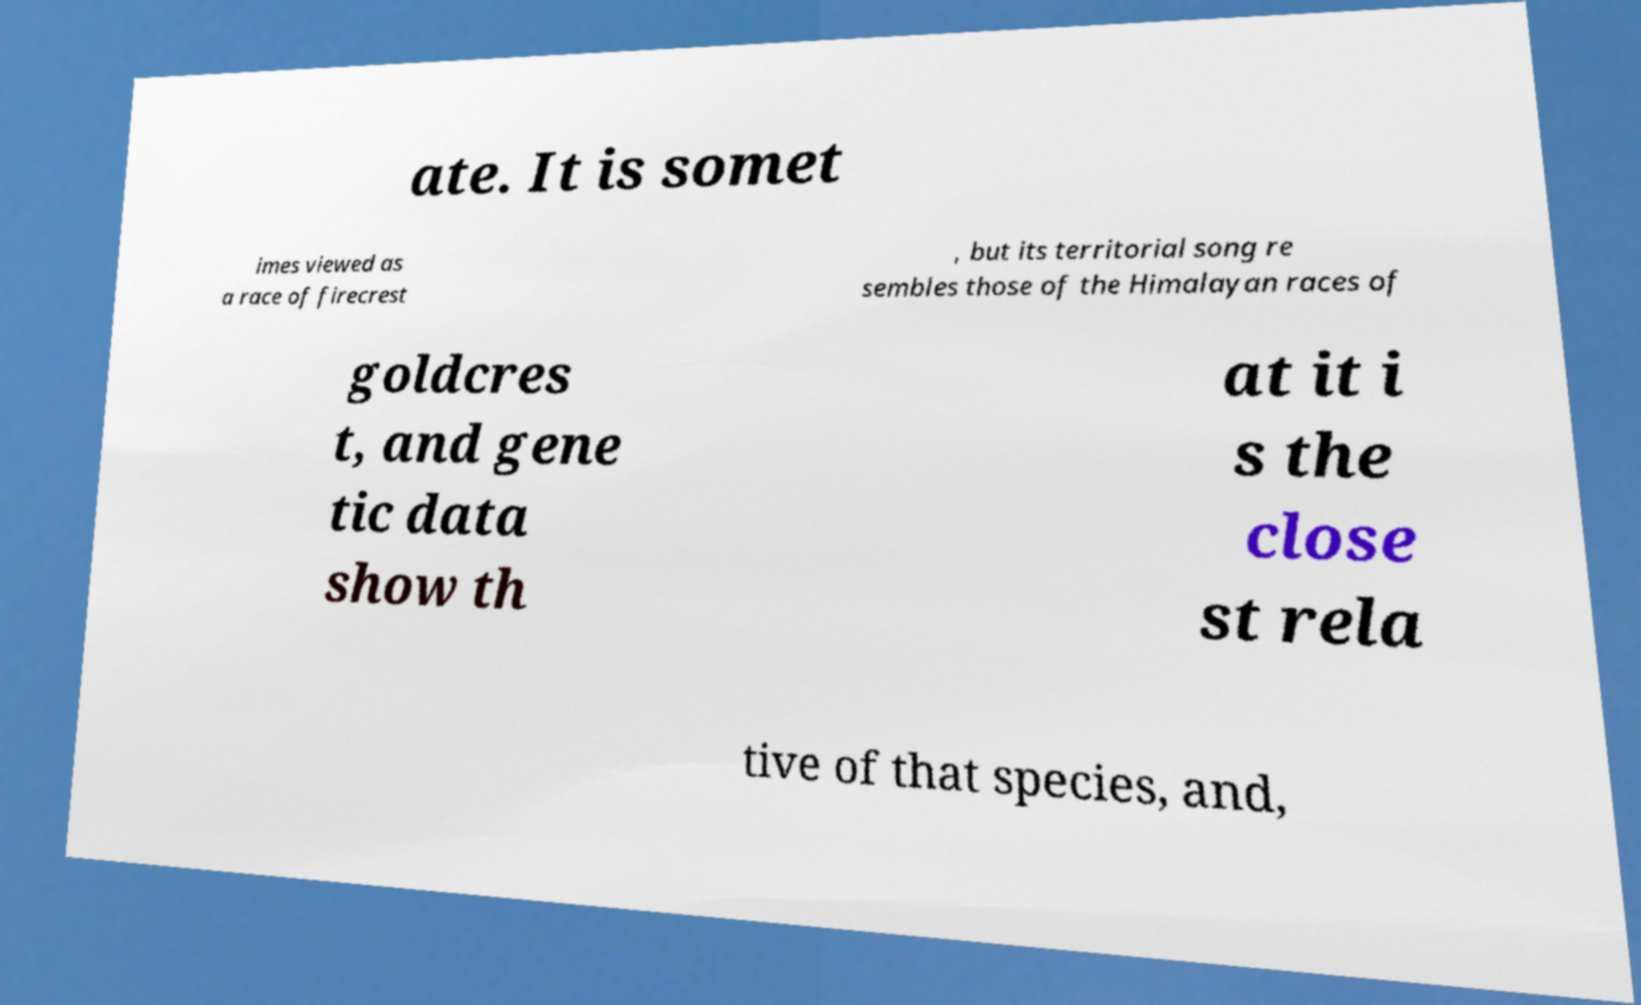Please identify and transcribe the text found in this image. ate. It is somet imes viewed as a race of firecrest , but its territorial song re sembles those of the Himalayan races of goldcres t, and gene tic data show th at it i s the close st rela tive of that species, and, 